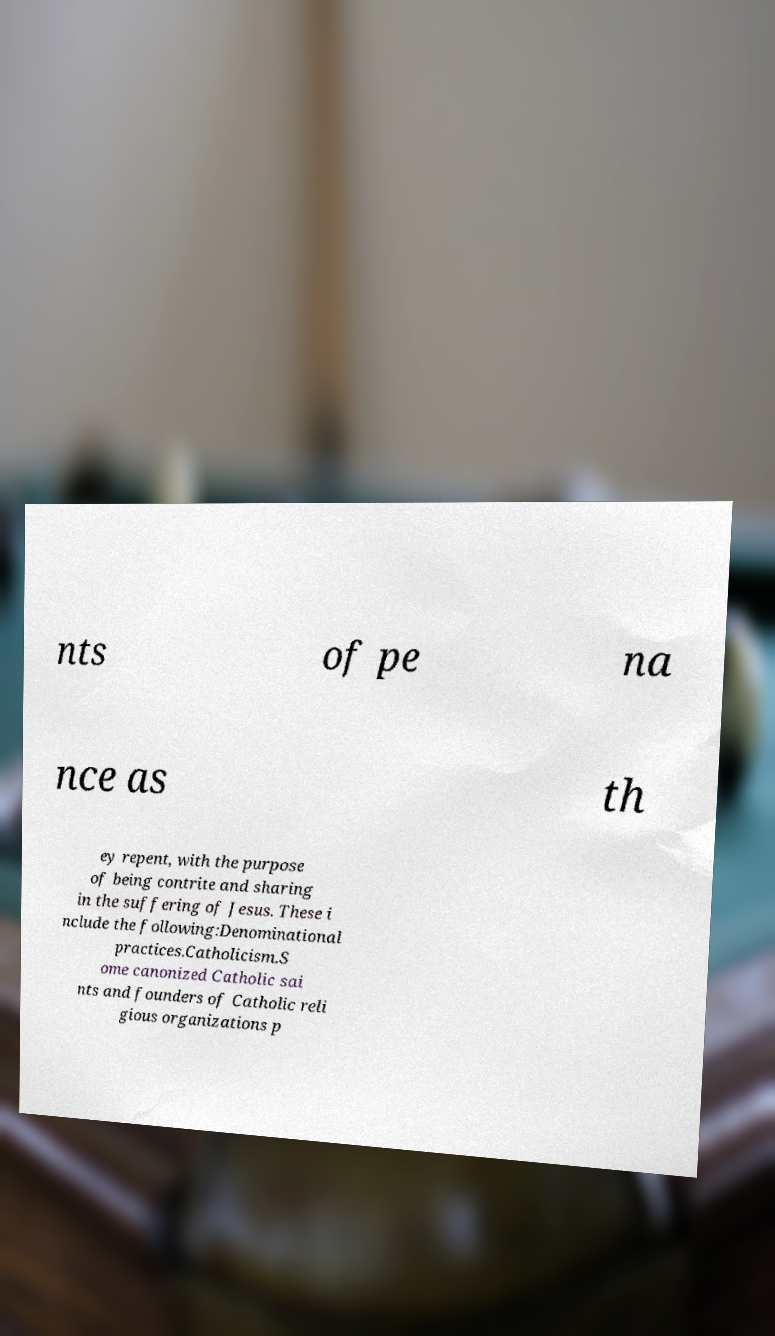There's text embedded in this image that I need extracted. Can you transcribe it verbatim? nts of pe na nce as th ey repent, with the purpose of being contrite and sharing in the suffering of Jesus. These i nclude the following:Denominational practices.Catholicism.S ome canonized Catholic sai nts and founders of Catholic reli gious organizations p 